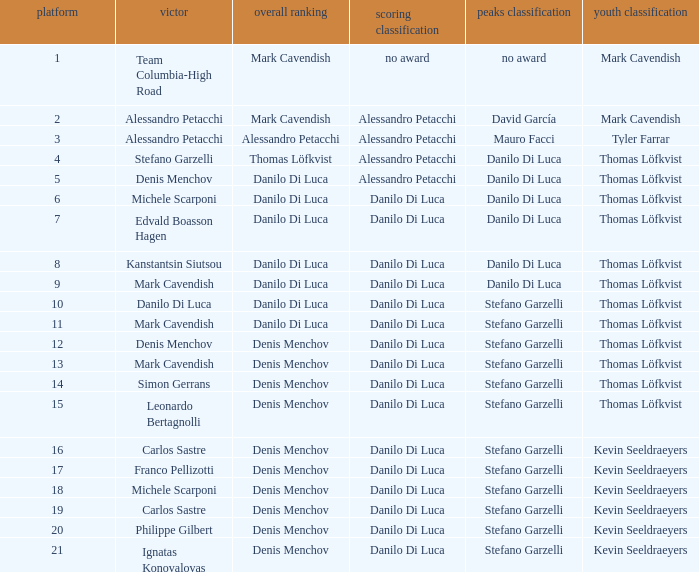When  thomas löfkvist is the general classification who is the winner? Stefano Garzelli. 